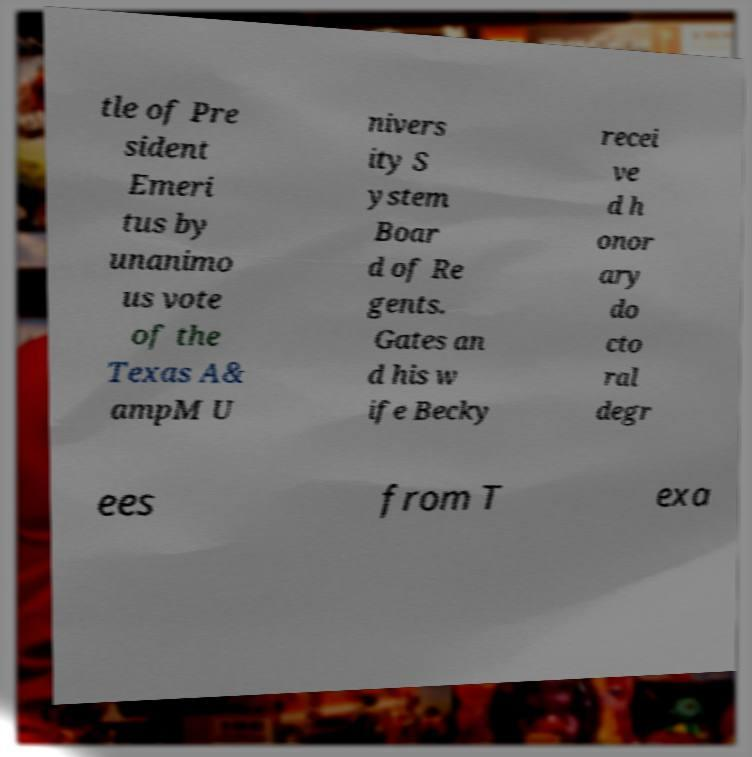Please identify and transcribe the text found in this image. tle of Pre sident Emeri tus by unanimo us vote of the Texas A& ampM U nivers ity S ystem Boar d of Re gents. Gates an d his w ife Becky recei ve d h onor ary do cto ral degr ees from T exa 